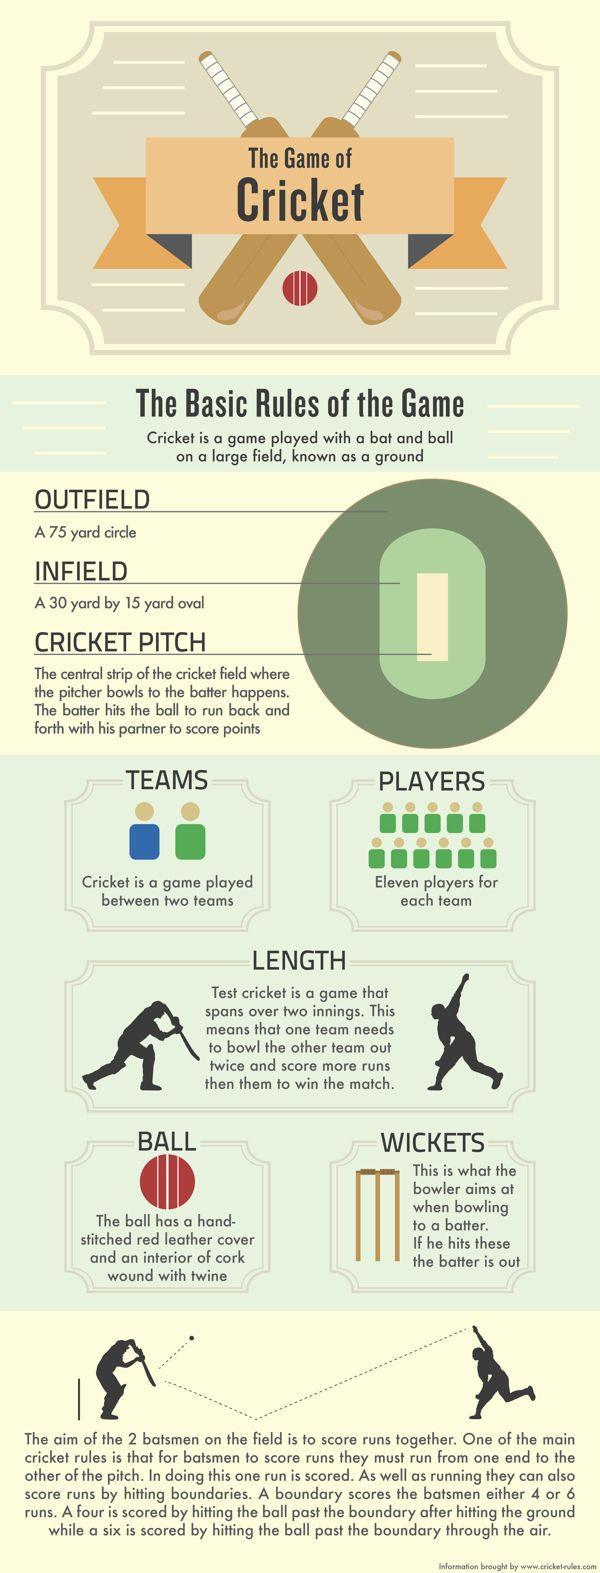How many bats are in this infographic?
Answer the question with a short phrase. 4 How many red balls are in this infographic? 2 